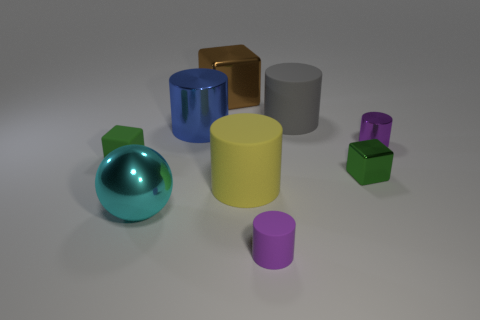How many green blocks must be subtracted to get 1 green blocks? 1 Subtract all blue cylinders. How many cylinders are left? 4 Subtract all yellow matte cylinders. How many cylinders are left? 4 Subtract all green cylinders. Subtract all blue cubes. How many cylinders are left? 5 Add 1 tiny purple rubber objects. How many objects exist? 10 Subtract all spheres. How many objects are left? 8 Subtract 1 blue cylinders. How many objects are left? 8 Subtract all big blue metallic objects. Subtract all large blue cylinders. How many objects are left? 7 Add 4 blue metal things. How many blue metal things are left? 5 Add 5 small red cylinders. How many small red cylinders exist? 5 